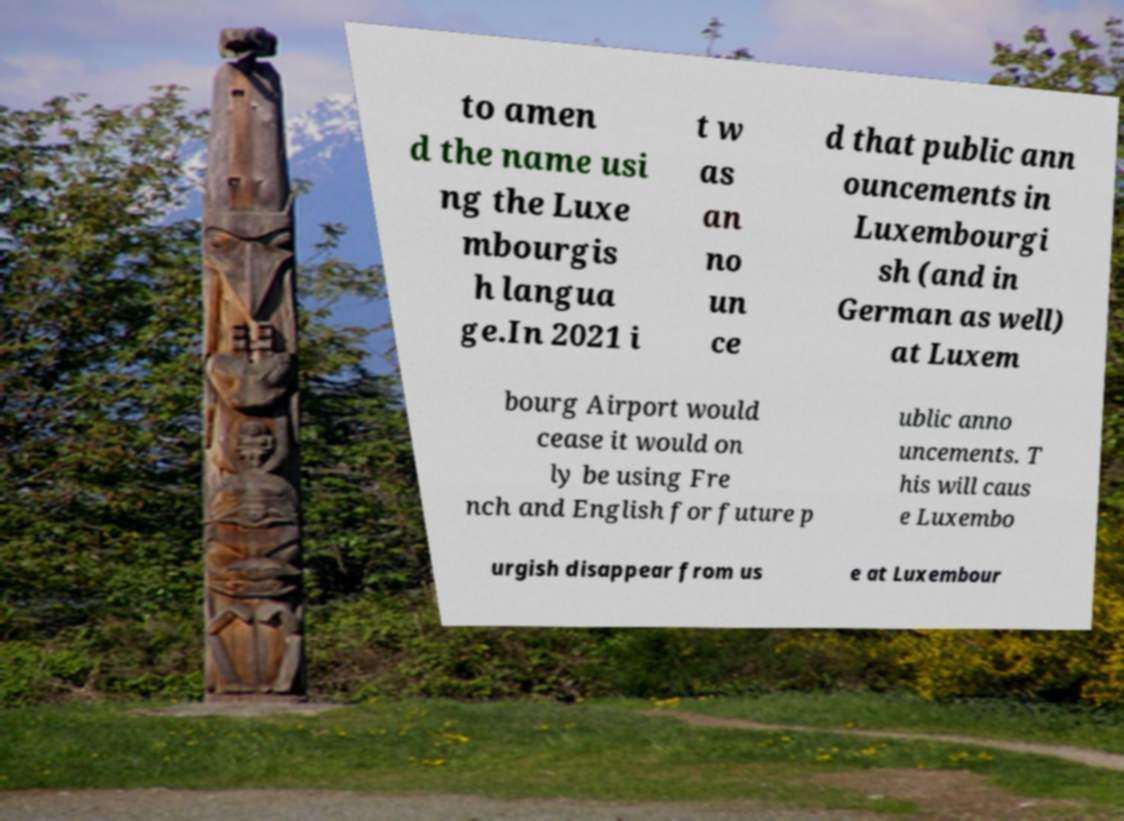Can you read and provide the text displayed in the image?This photo seems to have some interesting text. Can you extract and type it out for me? to amen d the name usi ng the Luxe mbourgis h langua ge.In 2021 i t w as an no un ce d that public ann ouncements in Luxembourgi sh (and in German as well) at Luxem bourg Airport would cease it would on ly be using Fre nch and English for future p ublic anno uncements. T his will caus e Luxembo urgish disappear from us e at Luxembour 